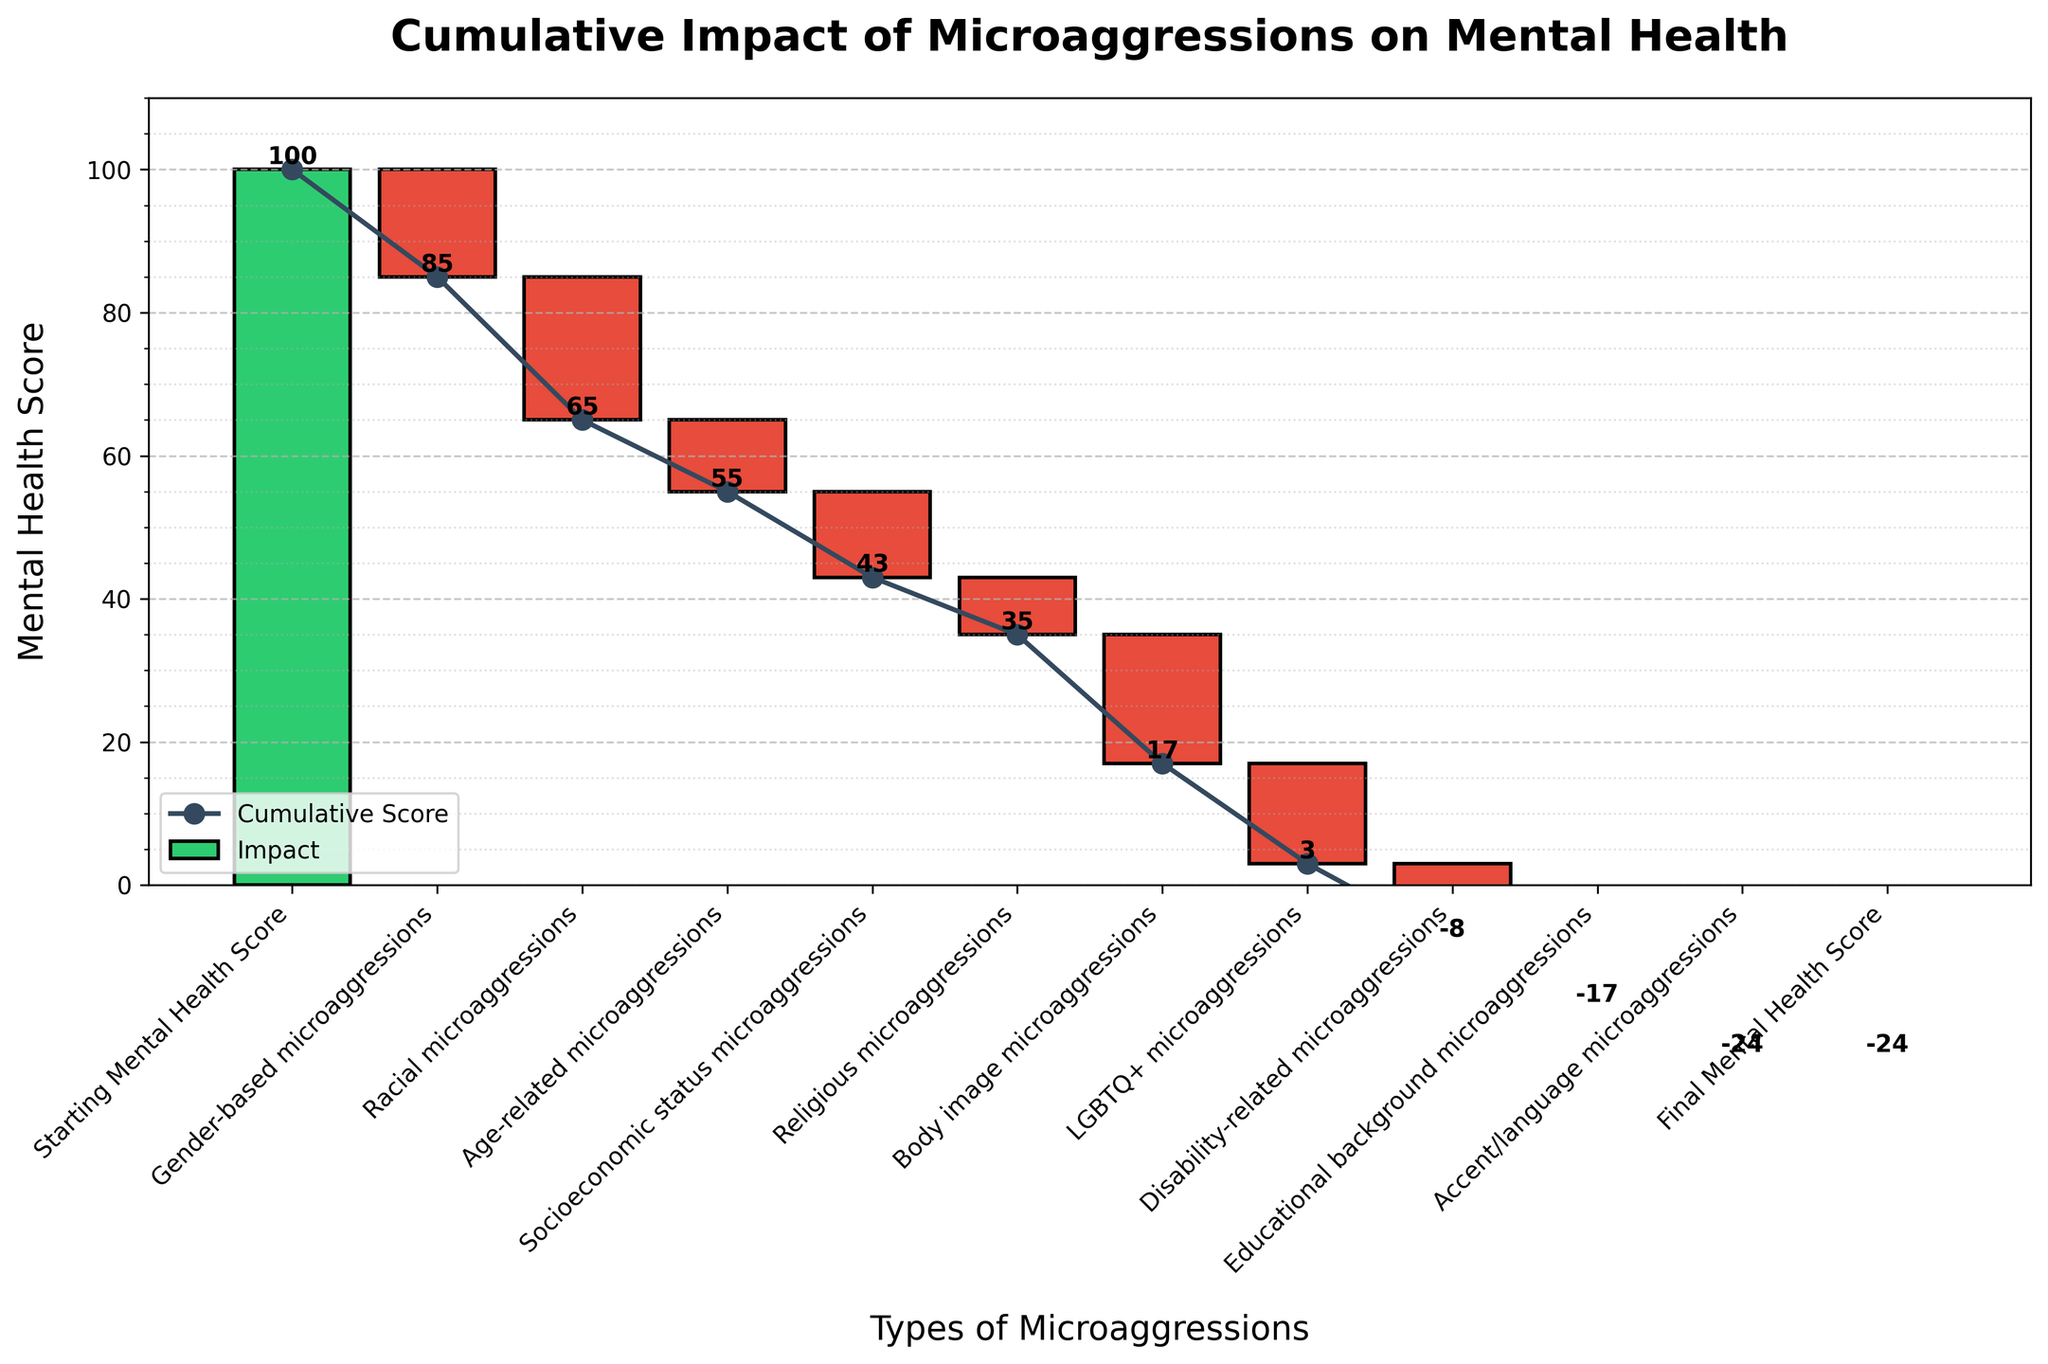What is the initial mental health score shown in the chart? The initial mental health score is represented by the "Starting Mental Health Score" bar in the chart, which is the first bar shown. It starts at the top of the chart indicating the starting point before any microaggressions' impact is accounted for.
Answer: 100 Which type of microaggression has the most negative impact on mental health? By comparing the negative values associated with each microaggression, we can see that "Racial microaggressions" have the highest negative impact with a value of -20.
Answer: Racial microaggressions What is the final mental health score after considering all microaggressions? The final mental health score is shown at the end of the cumulative impact line and is labeled as "Final Mental Health Score". According to the data, the final score is at 0.
Answer: 0 How much does "Gender-based microaggressions" contribute to the decline in mental health? "Gender-based microaggressions" cause a decrease of 15 in the mental health score, as indicated by its value of -15 in the chart.
Answer: -15 What is the cumulative mental health score after accounting for "Body image microaggressions"? To find this, start from the initial score of 100 and subtract the impacts of each microaggression up to and including "Body image microaggressions". The cumulative value is: 100 - 15 (Gender-based) - 20 (Racial) - 10 (Age-related) - 12 (Socioeconomic) - 8 (Religious) - 18 (Body image) = 17.
Answer: 17 Are there any microaggressions that cause a decrease of less than 10 points? By examining the values associated with each type of microaggression, "Religious microaggressions" (-8), "Accent/language microaggressions" (-7), and "Educational background microaggressions" (-9) each cause a decrease of less than 10 points.
Answer: Yes, three Which type of microaggression has the least impact on mental health? By comparing all the negative values, we see that "Accent/language microaggressions" have the least impact with a value of -7.
Answer: Accent/language microaggressions What is the total negative impact of "LGBTQ+ microaggressions" and "Disability-related microaggressions"? Sum the impacts of "LGBTQ+ microaggressions" (-14) and "Disability-related microaggressions" (-11): -14 + -11 = -25.
Answer: -25 Between "Socioeconomic status microaggressions" and "Disability-related microaggressions", which one has a greater impact, and by how much? "Socioeconomic status microaggressions" have an impact of -12, and "Disability-related microaggressions" have an impact of -11. The difference is 12 - 11 = 1.
Answer: Socioeconomic status microaggressions, by 1 What is the cumulative impact on mental health before and after "Educational background microaggressions"? Before "Educational background microaggressions", the cumulative score is 0 + (-15) + (-20) + (-10) + (-12) + (-8) + (-18) + (-14) + (-11) = -108. After including "Educational background microaggressions", it is -108 - 9 = -117.
Answer: Before: -108, After: -117 